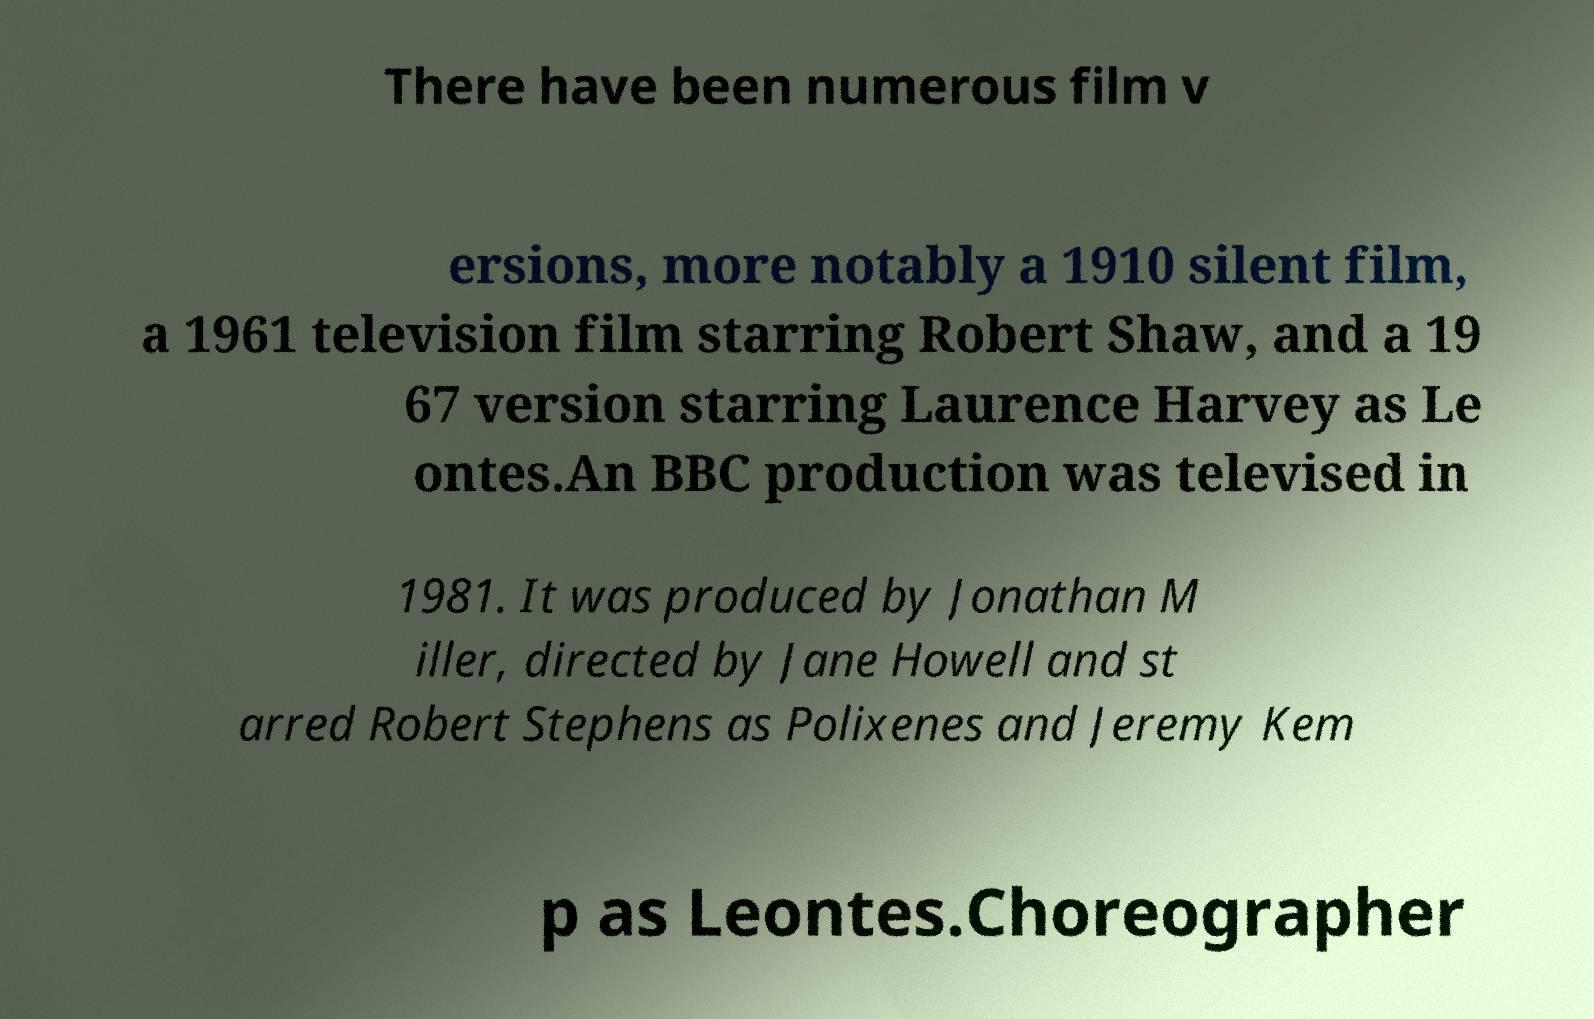For documentation purposes, I need the text within this image transcribed. Could you provide that? There have been numerous film v ersions, more notably a 1910 silent film, a 1961 television film starring Robert Shaw, and a 19 67 version starring Laurence Harvey as Le ontes.An BBC production was televised in 1981. It was produced by Jonathan M iller, directed by Jane Howell and st arred Robert Stephens as Polixenes and Jeremy Kem p as Leontes.Choreographer 